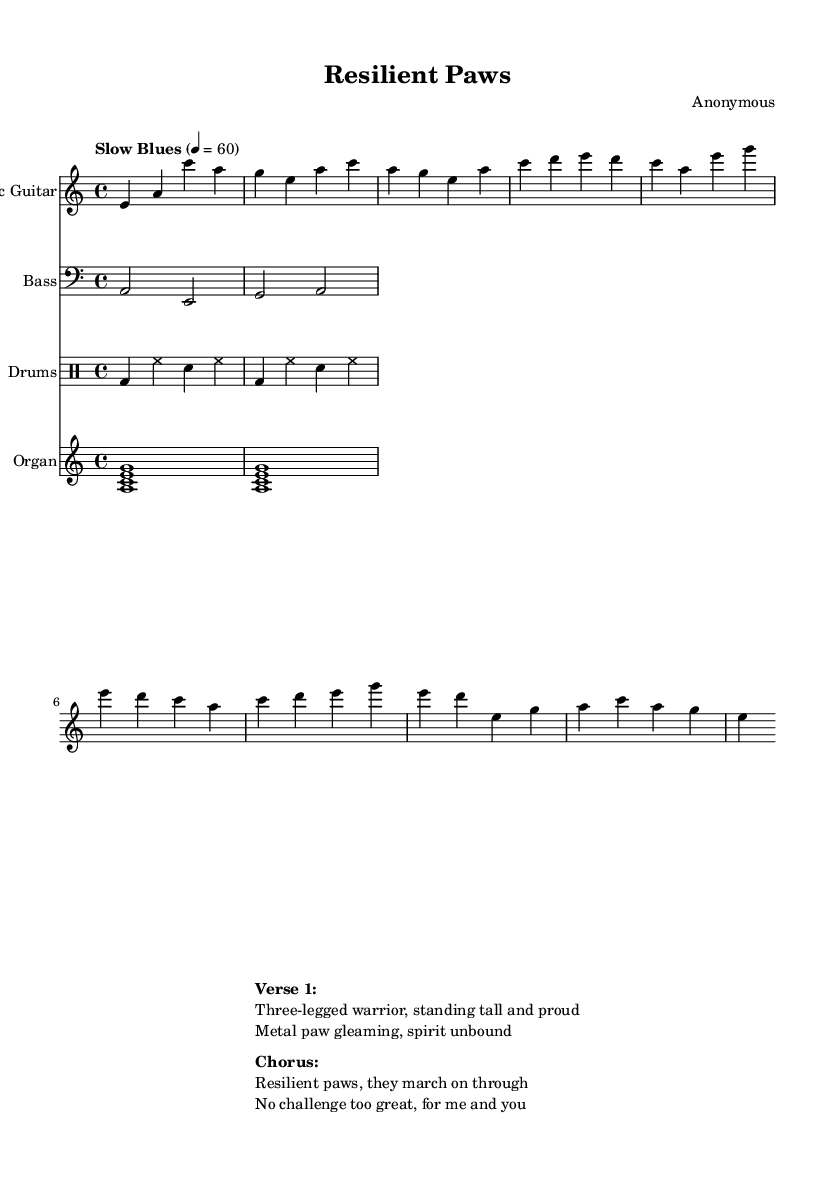What is the key signature of this music? The key signature is A minor, which consists of no sharps or flats. This can be determined from the beginning of the score, where the key signature is indicated.
Answer: A minor What is the time signature of the piece? The time signature is 4/4, which is indicated at the beginning of the sheet music. This means there are four beats in each measure, with a quarter note receiving one beat.
Answer: 4/4 What is the tempo marking for this music? The tempo marking is "Slow Blues," which indicates a relaxed and soulful pace. It is typically associated with blues music. The specific metronome setting of 60 BPM is also provided.
Answer: Slow Blues How many measures are in the verse section? The verse section consists of four measures, as can be seen by counting the separate segments in the guitar music. Each line is comprised of measures, and the verse is clearly defined within the score.
Answer: Four What instruments are included in this score? The score includes electric guitar, bass, drums, and organ, which are specified at the beginning of each staff in the score. Each instrument is labeled accordingly, providing clarity on the arrangement.
Answer: Electric guitar, bass, drums, organ What is the main theme expressed in the lyrics of Verse 1? The main theme expressed is resilience and strength, as indicated by the lyrics that talk about a "three-legged warrior" and the "spirit unbound." This shows a focus on overcoming challenges, particularly for animals with prosthetics.
Answer: Resilience 